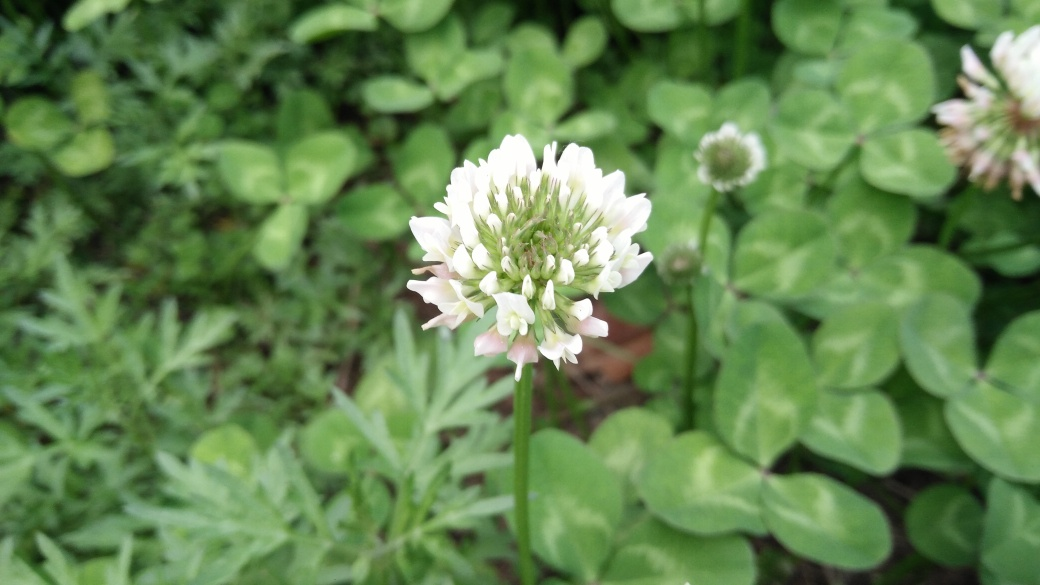What kind of flower is shown in the image? The flower in the image is a clover flower, known for its rounded shape and small, delicate florets. It's often found in grassy areas and serves as an important source of nectar for bees. Can you tell me about the plant's habitat preferences? Certainly! Clover plants typically prefer sunny areas with well-drained soil. They are quite adaptable though and can also be found in partially shaded environments. They're common in meadows, lawns, and even roadsides. 